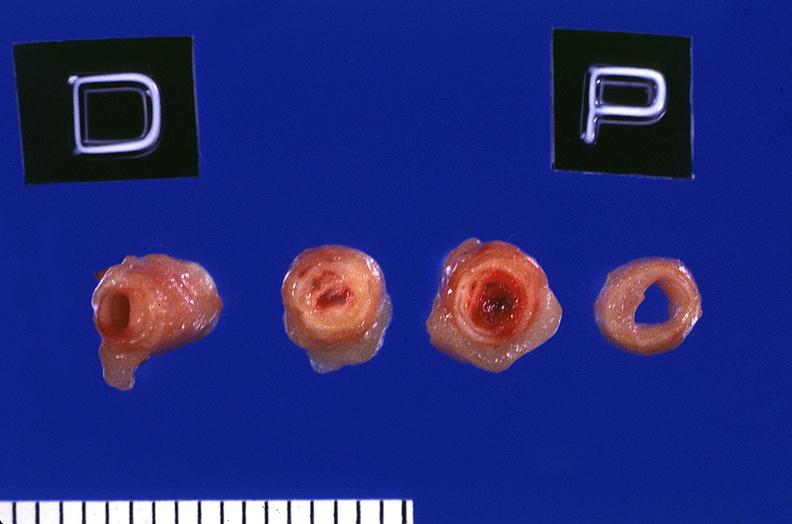does carcinomatosis show coronary artery with atherosclerosis and thrombotic occlusion?
Answer the question using a single word or phrase. No 